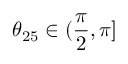<formula> <loc_0><loc_0><loc_500><loc_500>\theta _ { 2 5 } \in ( \frac { \pi } { 2 } , \pi ]</formula> 